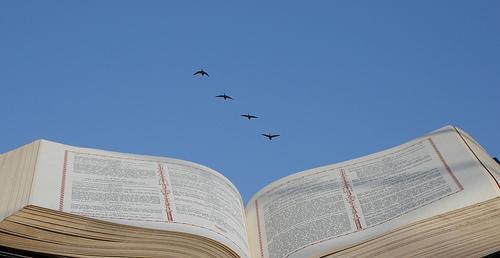How many birds are in the sky?
Give a very brief answer. 4. How many dinosaurs are in the picture?
Give a very brief answer. 0. How many clouds are in the sky?
Give a very brief answer. 0. 